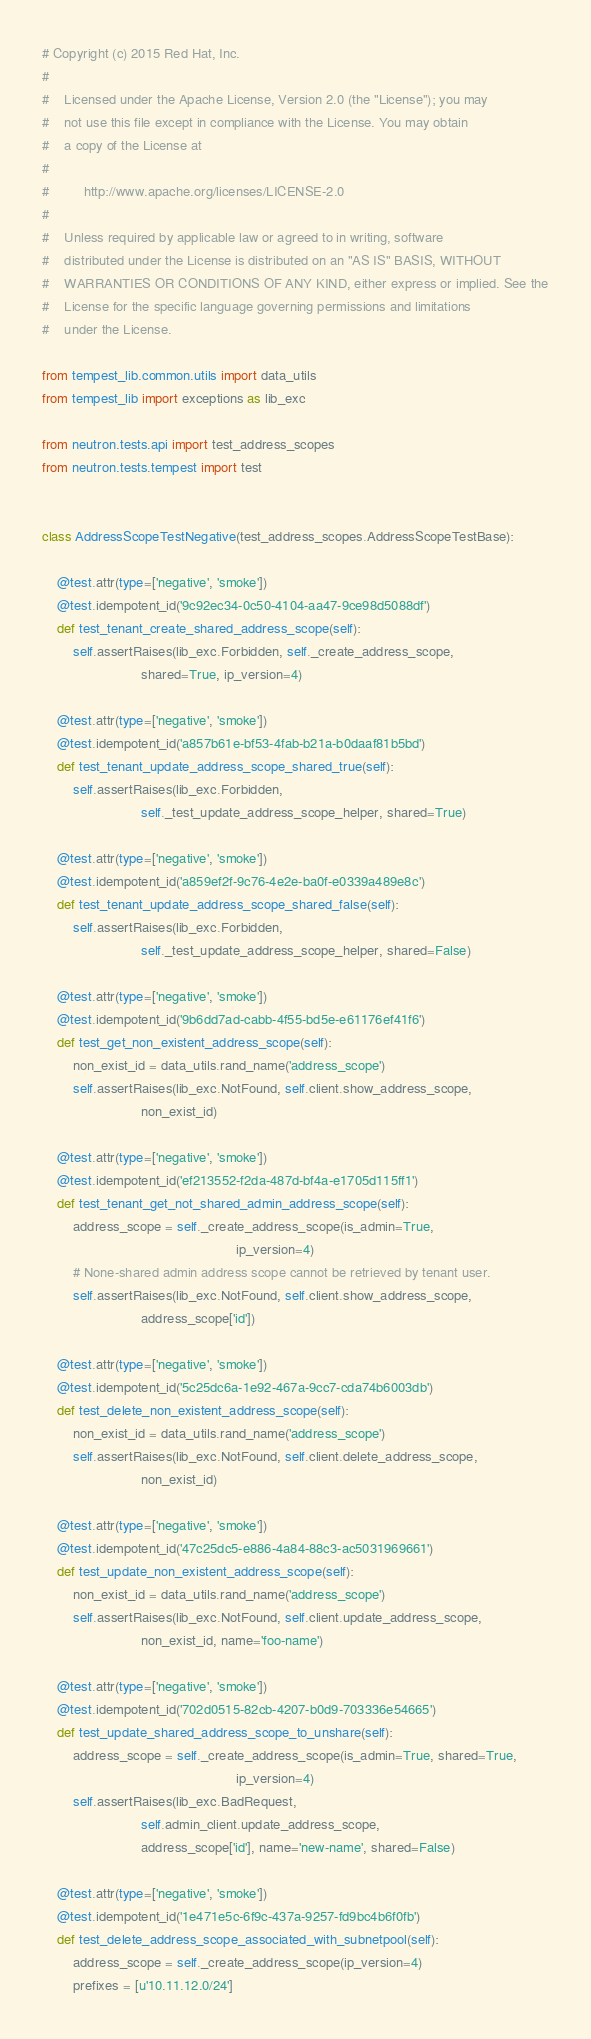Convert code to text. <code><loc_0><loc_0><loc_500><loc_500><_Python_># Copyright (c) 2015 Red Hat, Inc.
#
#    Licensed under the Apache License, Version 2.0 (the "License"); you may
#    not use this file except in compliance with the License. You may obtain
#    a copy of the License at
#
#         http://www.apache.org/licenses/LICENSE-2.0
#
#    Unless required by applicable law or agreed to in writing, software
#    distributed under the License is distributed on an "AS IS" BASIS, WITHOUT
#    WARRANTIES OR CONDITIONS OF ANY KIND, either express or implied. See the
#    License for the specific language governing permissions and limitations
#    under the License.

from tempest_lib.common.utils import data_utils
from tempest_lib import exceptions as lib_exc

from neutron.tests.api import test_address_scopes
from neutron.tests.tempest import test


class AddressScopeTestNegative(test_address_scopes.AddressScopeTestBase):

    @test.attr(type=['negative', 'smoke'])
    @test.idempotent_id('9c92ec34-0c50-4104-aa47-9ce98d5088df')
    def test_tenant_create_shared_address_scope(self):
        self.assertRaises(lib_exc.Forbidden, self._create_address_scope,
                          shared=True, ip_version=4)

    @test.attr(type=['negative', 'smoke'])
    @test.idempotent_id('a857b61e-bf53-4fab-b21a-b0daaf81b5bd')
    def test_tenant_update_address_scope_shared_true(self):
        self.assertRaises(lib_exc.Forbidden,
                          self._test_update_address_scope_helper, shared=True)

    @test.attr(type=['negative', 'smoke'])
    @test.idempotent_id('a859ef2f-9c76-4e2e-ba0f-e0339a489e8c')
    def test_tenant_update_address_scope_shared_false(self):
        self.assertRaises(lib_exc.Forbidden,
                          self._test_update_address_scope_helper, shared=False)

    @test.attr(type=['negative', 'smoke'])
    @test.idempotent_id('9b6dd7ad-cabb-4f55-bd5e-e61176ef41f6')
    def test_get_non_existent_address_scope(self):
        non_exist_id = data_utils.rand_name('address_scope')
        self.assertRaises(lib_exc.NotFound, self.client.show_address_scope,
                          non_exist_id)

    @test.attr(type=['negative', 'smoke'])
    @test.idempotent_id('ef213552-f2da-487d-bf4a-e1705d115ff1')
    def test_tenant_get_not_shared_admin_address_scope(self):
        address_scope = self._create_address_scope(is_admin=True,
                                                   ip_version=4)
        # None-shared admin address scope cannot be retrieved by tenant user.
        self.assertRaises(lib_exc.NotFound, self.client.show_address_scope,
                          address_scope['id'])

    @test.attr(type=['negative', 'smoke'])
    @test.idempotent_id('5c25dc6a-1e92-467a-9cc7-cda74b6003db')
    def test_delete_non_existent_address_scope(self):
        non_exist_id = data_utils.rand_name('address_scope')
        self.assertRaises(lib_exc.NotFound, self.client.delete_address_scope,
                          non_exist_id)

    @test.attr(type=['negative', 'smoke'])
    @test.idempotent_id('47c25dc5-e886-4a84-88c3-ac5031969661')
    def test_update_non_existent_address_scope(self):
        non_exist_id = data_utils.rand_name('address_scope')
        self.assertRaises(lib_exc.NotFound, self.client.update_address_scope,
                          non_exist_id, name='foo-name')

    @test.attr(type=['negative', 'smoke'])
    @test.idempotent_id('702d0515-82cb-4207-b0d9-703336e54665')
    def test_update_shared_address_scope_to_unshare(self):
        address_scope = self._create_address_scope(is_admin=True, shared=True,
                                                   ip_version=4)
        self.assertRaises(lib_exc.BadRequest,
                          self.admin_client.update_address_scope,
                          address_scope['id'], name='new-name', shared=False)

    @test.attr(type=['negative', 'smoke'])
    @test.idempotent_id('1e471e5c-6f9c-437a-9257-fd9bc4b6f0fb')
    def test_delete_address_scope_associated_with_subnetpool(self):
        address_scope = self._create_address_scope(ip_version=4)
        prefixes = [u'10.11.12.0/24']</code> 